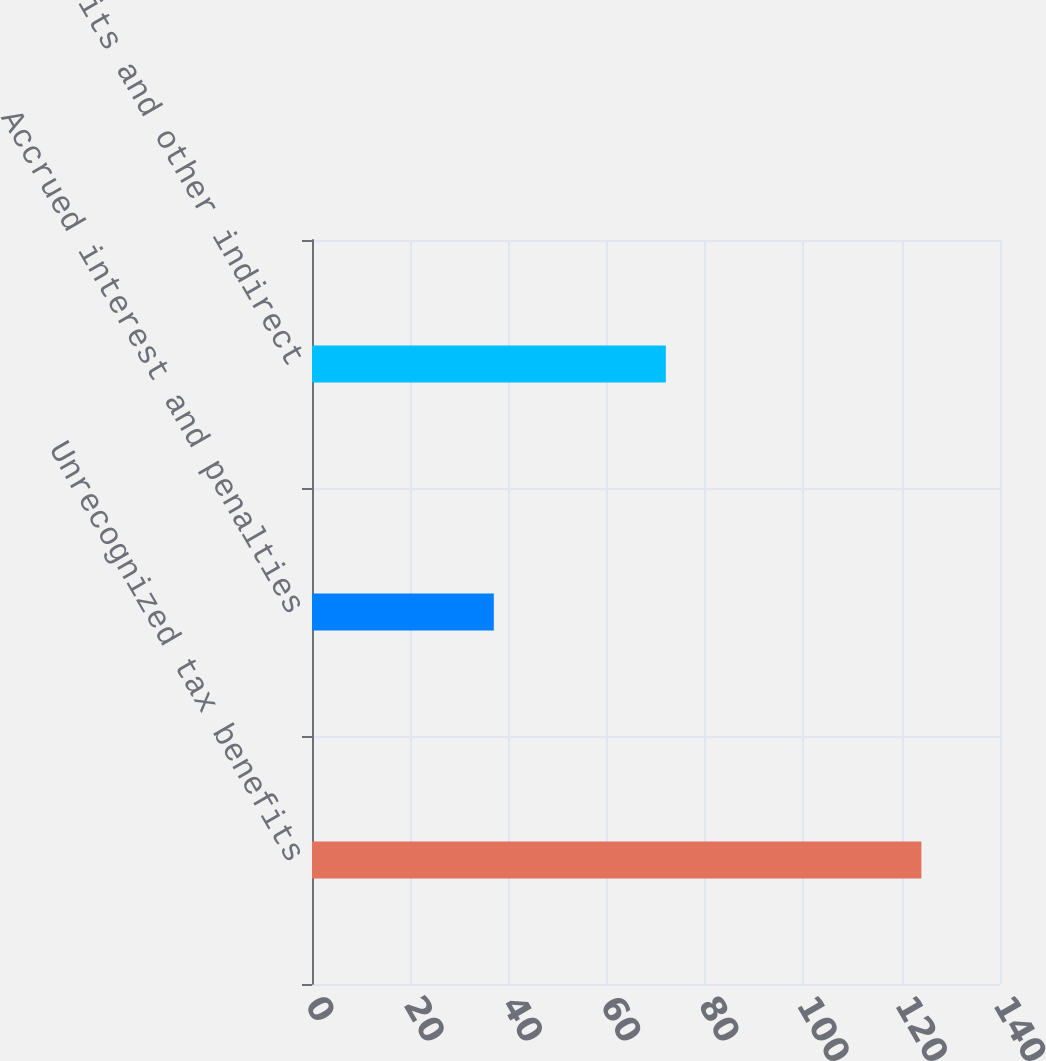Convert chart to OTSL. <chart><loc_0><loc_0><loc_500><loc_500><bar_chart><fcel>Unrecognized tax benefits<fcel>Accrued interest and penalties<fcel>Tax credits and other indirect<nl><fcel>124<fcel>37<fcel>72<nl></chart> 